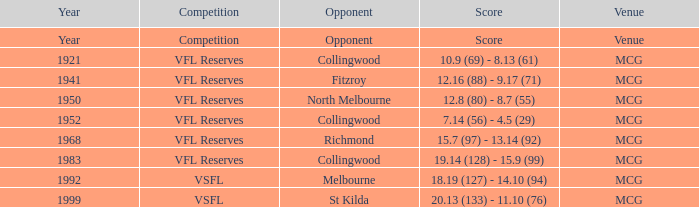5 (29)? MCG. 